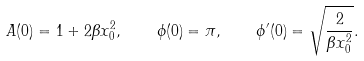<formula> <loc_0><loc_0><loc_500><loc_500>A ( 0 ) = 1 + 2 \beta x _ { 0 } ^ { 2 } , \quad \phi ( 0 ) = \pi , \quad \phi ^ { \prime } ( 0 ) = \sqrt { \frac { 2 } { \beta x _ { 0 } ^ { 2 } } } .</formula> 